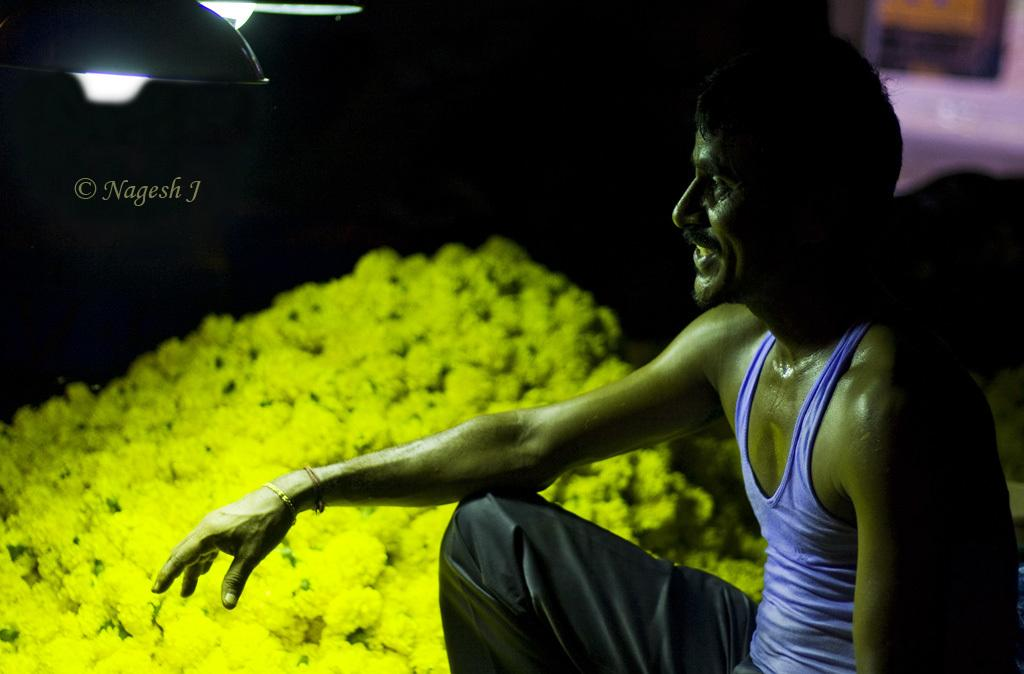What is the main subject of the image? There is a person in the center of the image. What can be seen in the background of the image? There are flowers in the background of the image. How many frogs are sitting on the person's stomach in the image? There are no frogs present in the image, and the person's stomach is not visible. 